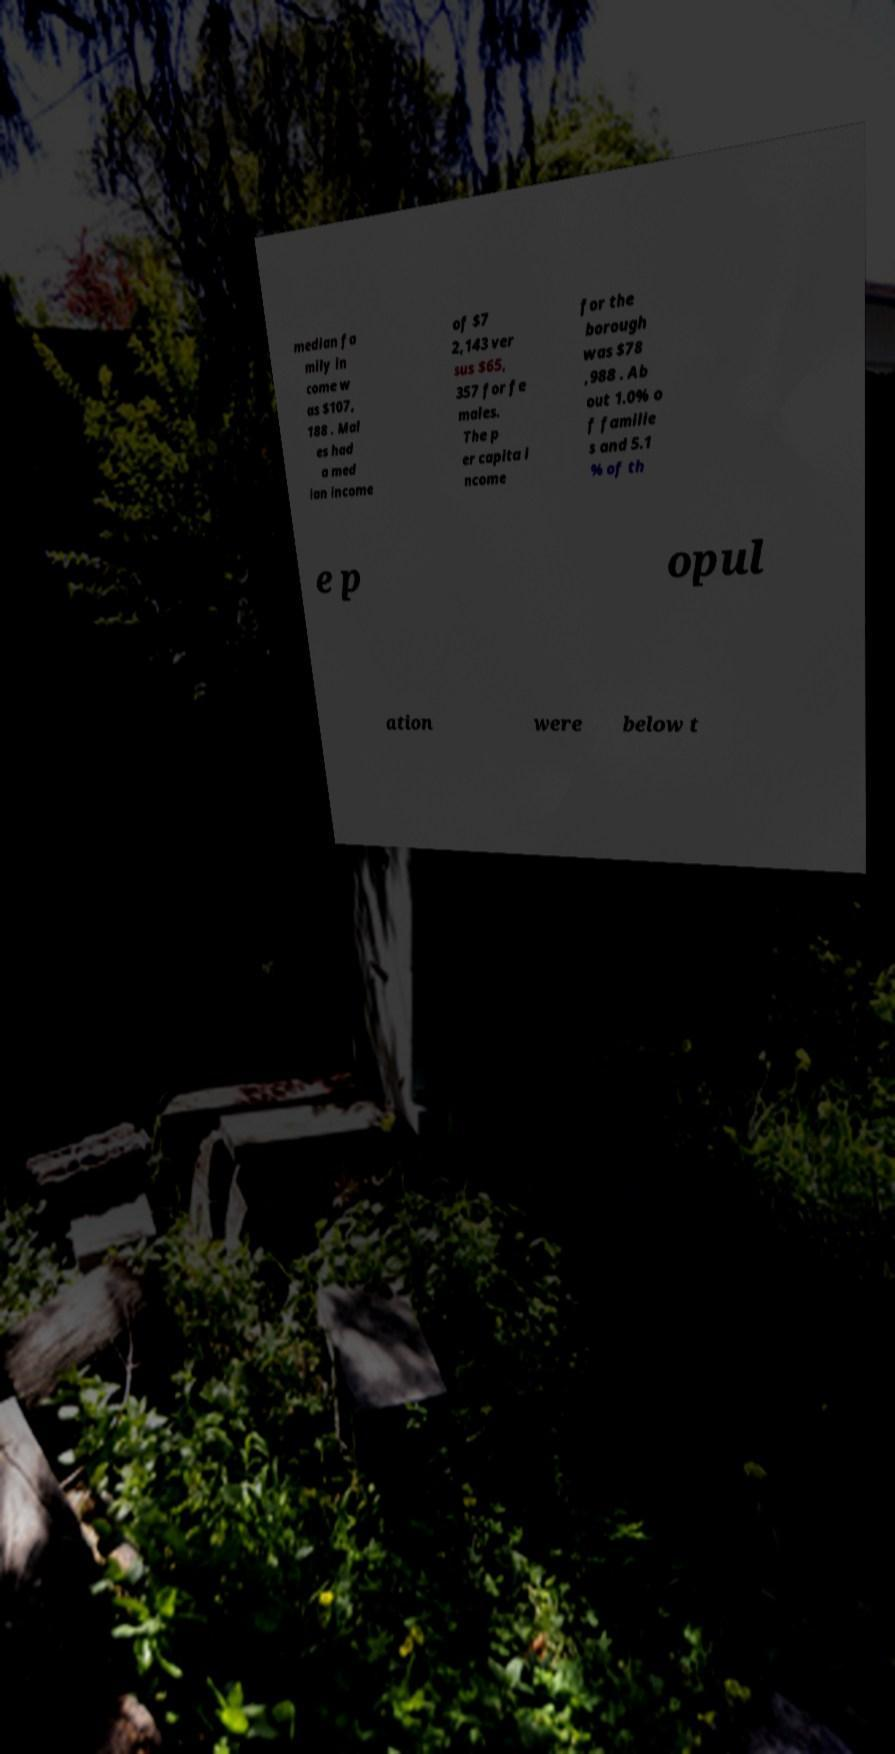Could you extract and type out the text from this image? median fa mily in come w as $107, 188 . Mal es had a med ian income of $7 2,143 ver sus $65, 357 for fe males. The p er capita i ncome for the borough was $78 ,988 . Ab out 1.0% o f familie s and 5.1 % of th e p opul ation were below t 